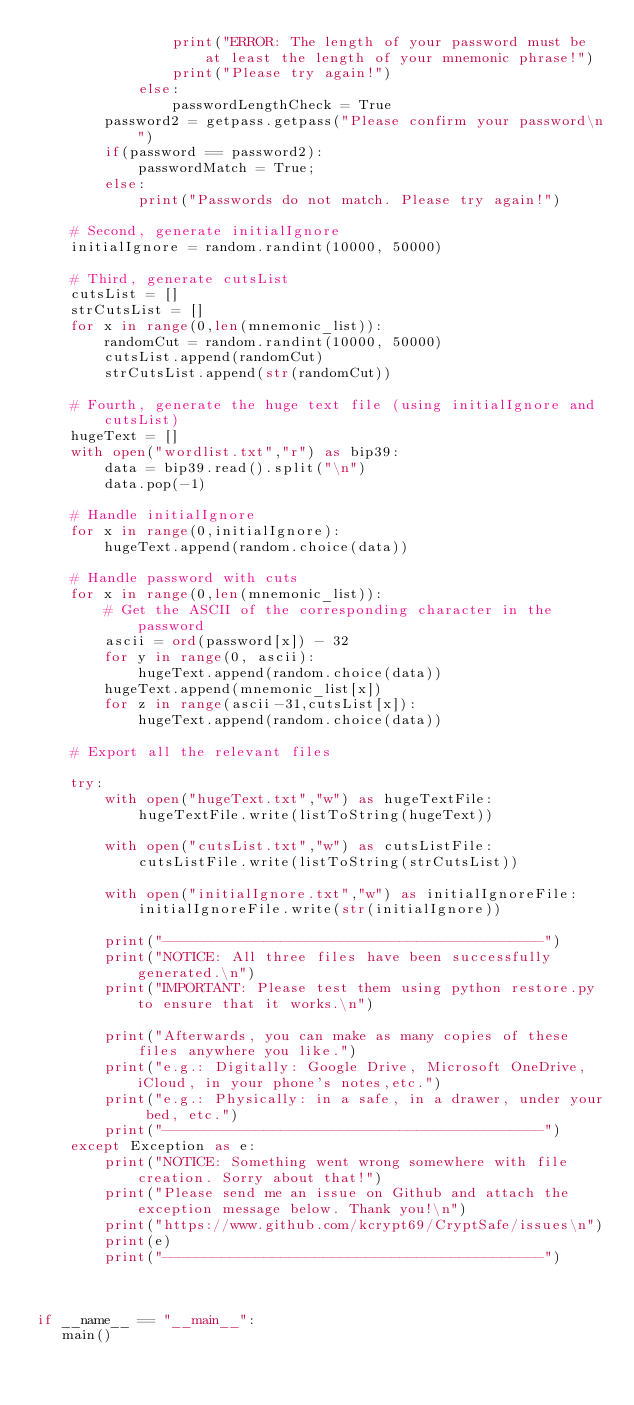Convert code to text. <code><loc_0><loc_0><loc_500><loc_500><_Python_>                print("ERROR: The length of your password must be at least the length of your mnemonic phrase!")
                print("Please try again!")
            else:
                passwordLengthCheck = True
        password2 = getpass.getpass("Please confirm your password\n")
        if(password == password2):
            passwordMatch = True;
        else:
            print("Passwords do not match. Please try again!")

    # Second, generate initialIgnore
    initialIgnore = random.randint(10000, 50000)

    # Third, generate cutsList
    cutsList = []
    strCutsList = []
    for x in range(0,len(mnemonic_list)):
        randomCut = random.randint(10000, 50000)
        cutsList.append(randomCut)
        strCutsList.append(str(randomCut))

    # Fourth, generate the huge text file (using initialIgnore and cutsList)
    hugeText = []
    with open("wordlist.txt","r") as bip39:
        data = bip39.read().split("\n")
        data.pop(-1)

    # Handle initialIgnore
    for x in range(0,initialIgnore):
        hugeText.append(random.choice(data))

    # Handle password with cuts
    for x in range(0,len(mnemonic_list)):
        # Get the ASCII of the corresponding character in the password
        ascii = ord(password[x]) - 32
        for y in range(0, ascii):
            hugeText.append(random.choice(data))
        hugeText.append(mnemonic_list[x])
        for z in range(ascii-31,cutsList[x]):
            hugeText.append(random.choice(data))

    # Export all the relevant files

    try:
        with open("hugeText.txt","w") as hugeTextFile:
            hugeTextFile.write(listToString(hugeText))

        with open("cutsList.txt","w") as cutsListFile:
            cutsListFile.write(listToString(strCutsList))

        with open("initialIgnore.txt","w") as initialIgnoreFile:
            initialIgnoreFile.write(str(initialIgnore))

        print("---------------------------------------------")
        print("NOTICE: All three files have been successfully generated.\n")
        print("IMPORTANT: Please test them using python restore.py to ensure that it works.\n")

        print("Afterwards, you can make as many copies of these files anywhere you like.")
        print("e.g.: Digitally: Google Drive, Microsoft OneDrive, iCloud, in your phone's notes,etc.")
        print("e.g.: Physically: in a safe, in a drawer, under your bed, etc.")
        print("---------------------------------------------")
    except Exception as e:
        print("NOTICE: Something went wrong somewhere with file creation. Sorry about that!")
        print("Please send me an issue on Github and attach the exception message below. Thank you!\n")
        print("https://www.github.com/kcrypt69/CryptSafe/issues\n")
        print(e)
        print("---------------------------------------------")



if __name__ == "__main__":
   main()
</code> 